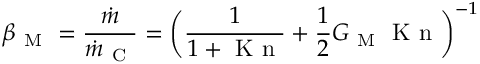Convert formula to latex. <formula><loc_0><loc_0><loc_500><loc_500>\beta _ { M } = \frac { \dot { m } } { \dot { m } _ { C } } = \left ( \frac { 1 } { 1 + K n } + \frac { 1 } { 2 } G _ { M } K n \right ) ^ { - 1 }</formula> 